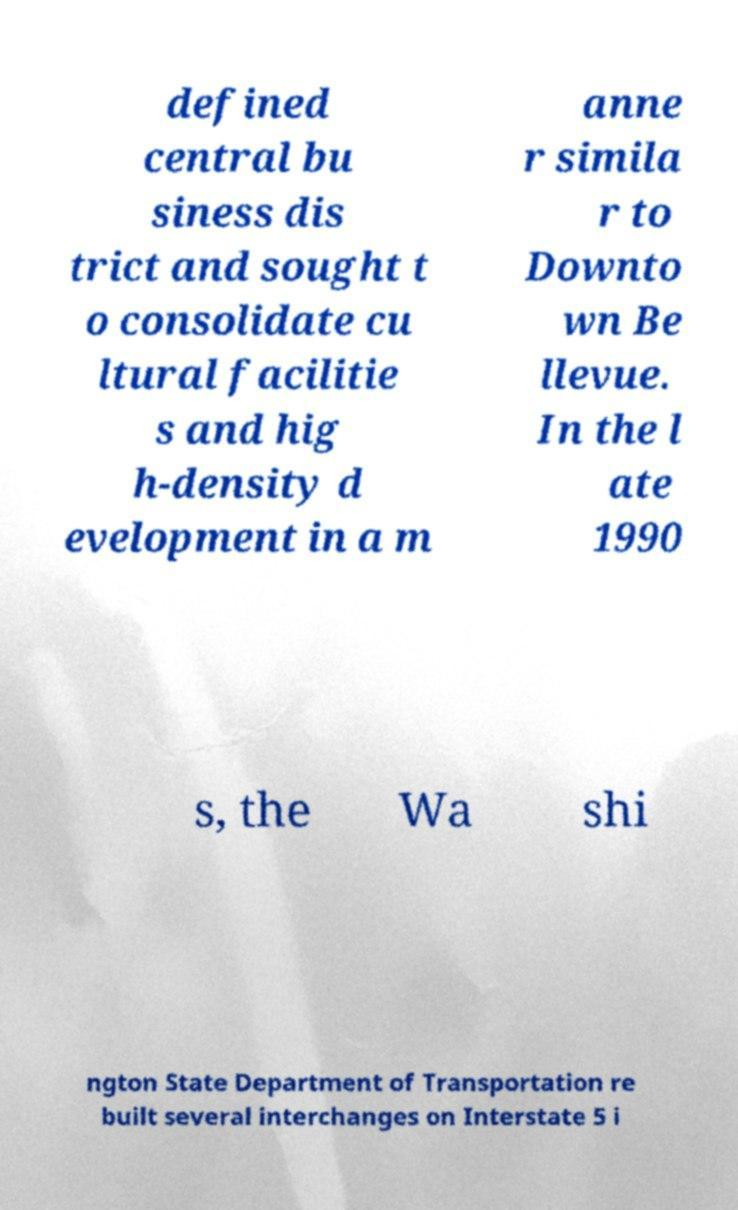Could you extract and type out the text from this image? defined central bu siness dis trict and sought t o consolidate cu ltural facilitie s and hig h-density d evelopment in a m anne r simila r to Downto wn Be llevue. In the l ate 1990 s, the Wa shi ngton State Department of Transportation re built several interchanges on Interstate 5 i 